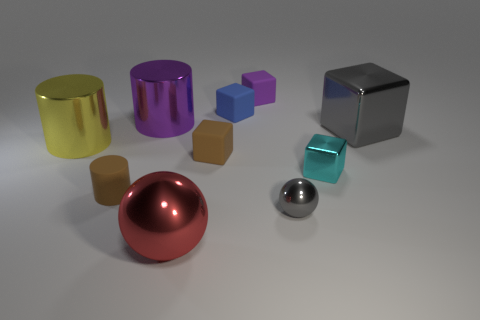Subtract all blue matte cubes. How many cubes are left? 4 Subtract all red balls. How many balls are left? 1 Subtract 5 blocks. How many blocks are left? 0 Add 6 small brown rubber cylinders. How many small brown rubber cylinders exist? 7 Subtract 1 purple cylinders. How many objects are left? 9 Subtract all cylinders. How many objects are left? 7 Subtract all brown cylinders. Subtract all green balls. How many cylinders are left? 2 Subtract all yellow shiny cylinders. Subtract all purple things. How many objects are left? 7 Add 4 matte things. How many matte things are left? 8 